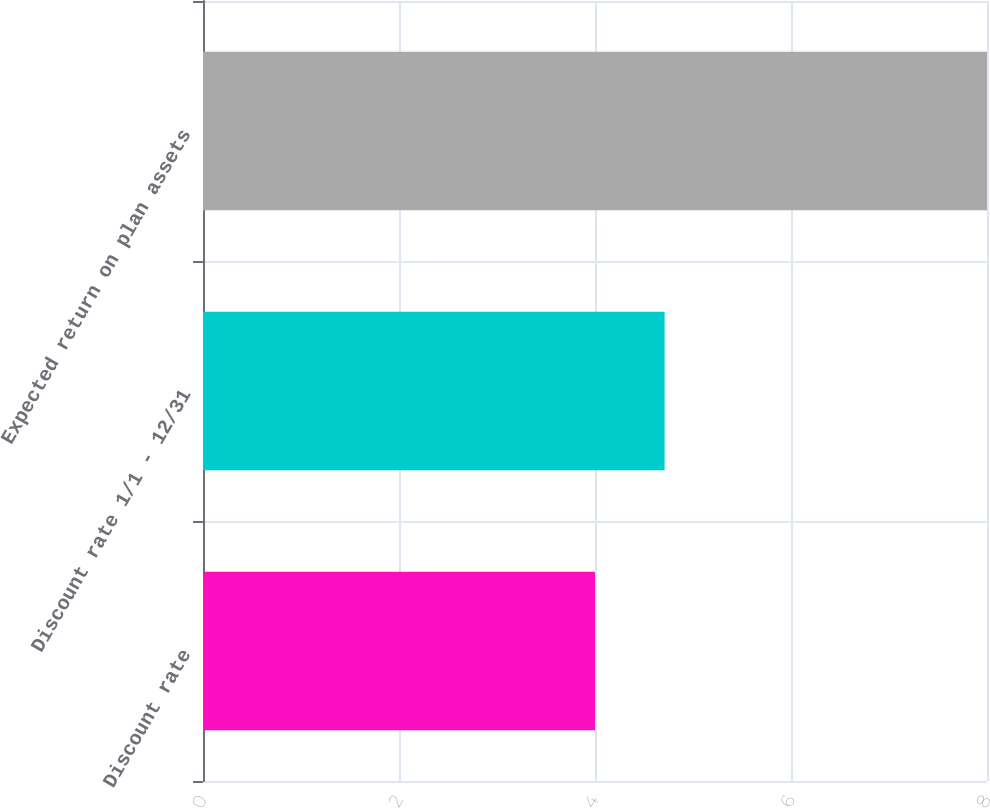<chart> <loc_0><loc_0><loc_500><loc_500><bar_chart><fcel>Discount rate<fcel>Discount rate 1/1 - 12/31<fcel>Expected return on plan assets<nl><fcel>4<fcel>4.71<fcel>8<nl></chart> 